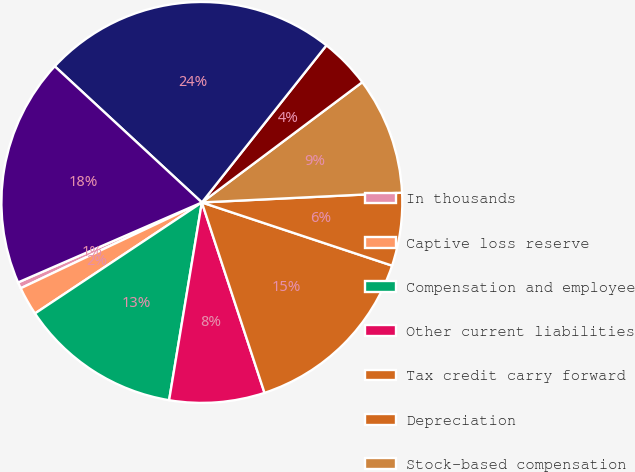Convert chart to OTSL. <chart><loc_0><loc_0><loc_500><loc_500><pie_chart><fcel>In thousands<fcel>Captive loss reserve<fcel>Compensation and employee<fcel>Other current liabilities<fcel>Tax credit carry forward<fcel>Depreciation<fcel>Stock-based compensation<fcel>Other<fcel>Gross deferred tax assets<fcel>Capitalized software<nl><fcel>0.51%<fcel>2.3%<fcel>13.04%<fcel>7.67%<fcel>14.83%<fcel>5.88%<fcel>9.46%<fcel>4.09%<fcel>23.78%<fcel>18.41%<nl></chart> 